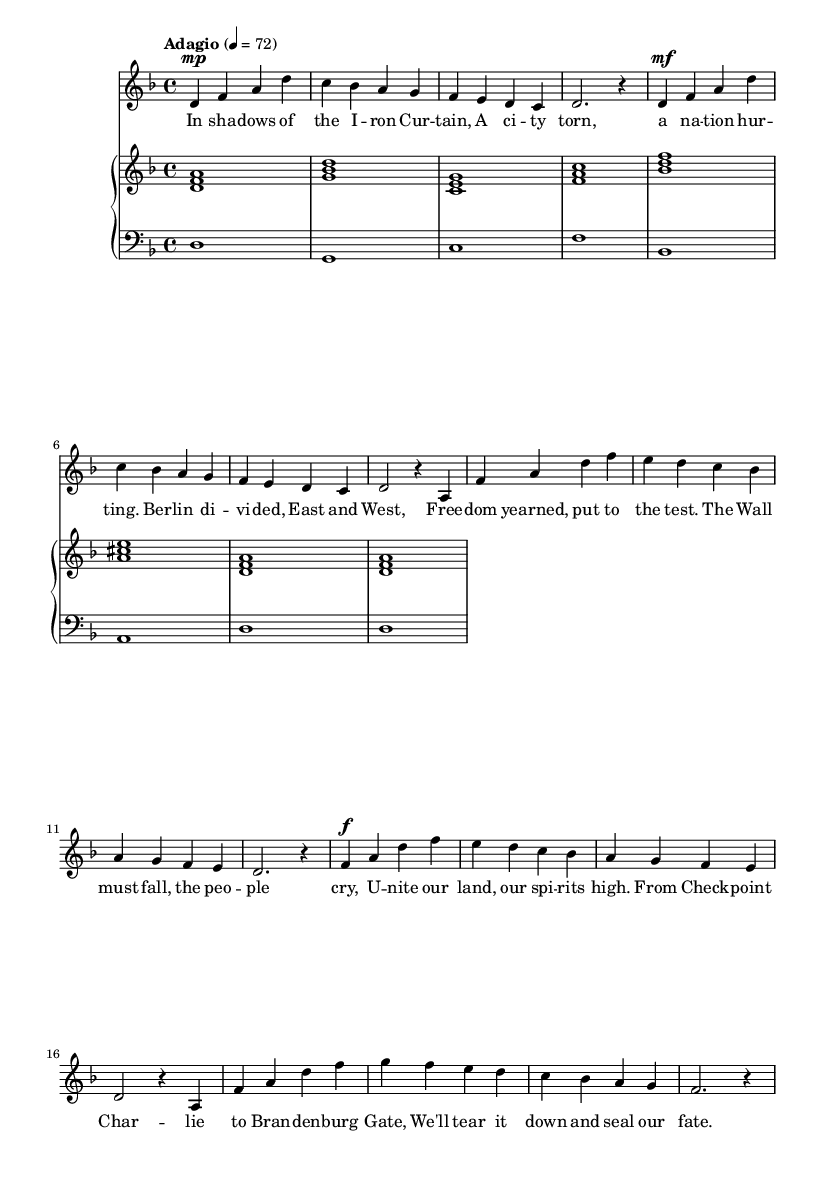What is the key signature of this music? The key signature is indicated by the number of sharps or flats at the beginning of the staff. In this music, there are no sharps or flats shown next to the clef, which indicates that the key signature is D minor as denoted in the global setting.
Answer: D minor What is the time signature of this music? The time signature is displayed as a fraction at the beginning of the piece. Here, it shows 4 over 4, meaning there are four beats in a measure and the quarter note gets one beat.
Answer: 4/4 What is the tempo marking for this piece? The tempo marking is described above the staff, indicating how fast the piece should be performed. In this music, it reads "Adagio" with a metronome marking of quarter note equals seventy-two, suggesting a slow pace.
Answer: Adagio Which section features the lyrics "The Wall must fall, the people cry"? By inspecting the lyrics provided under the music notation, we can see that these specific lyrics appear during the chorus section, which is indicated in the scoring.
Answer: Chorus How many distinct sections are there in this opera aria? The sections of the aria can be identified visually. In this case, there are three distinct sections labeled as Introduction, Verse 1, and Chorus.
Answer: Three What do the dynamics indicate for the first verse? Dynamics are indicated by symbols such as 'mp' and 'mf' throughout the piece. The first verse shows 'mp' which stands for mezzo-piano, meaning moderately soft, and then switches to 'mf' which stands for mezzo-forte, meaning moderately loud.
Answer: mp, mf What is the style of this music as indicated in its genre? The style of the music is classified by its structure and content typical of operas, which often include a narrative element and express deep emotions through dramatic vocal lines, focusing on historical or political themes as depicted here.
Answer: Opera 